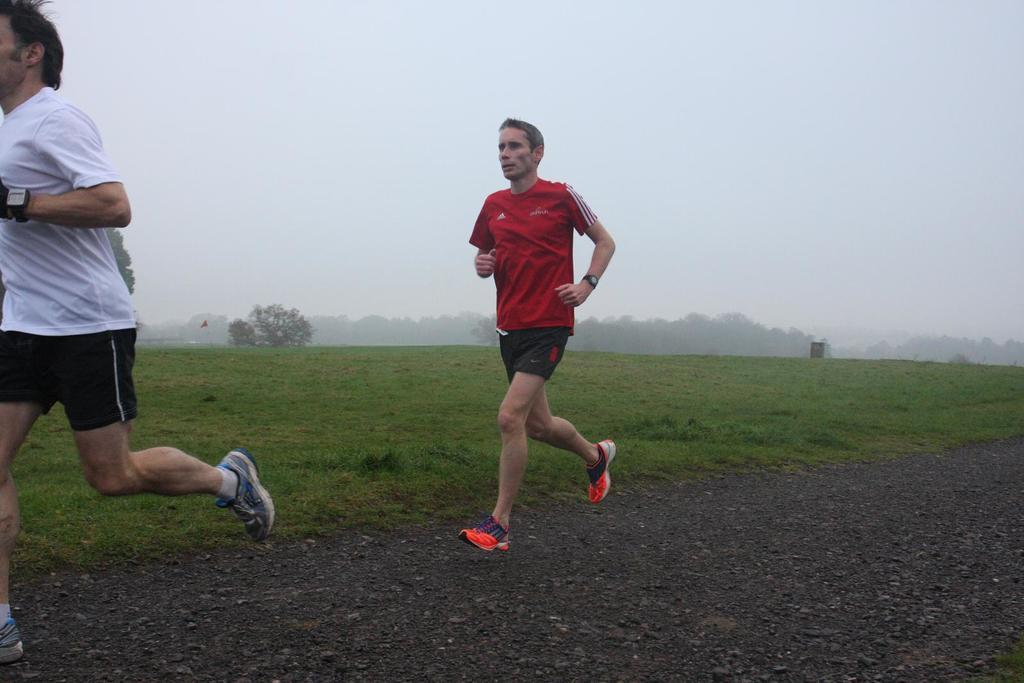How many people are in the image? There are two men in the image. What are the men doing in the image? The men are jogging. What type of terrain surrounds the men? The land around them is covered with grass. Are there any trees visible in the image? Yes, there are trees in the image. How would you describe the weather in the image? The climate is cool with fog. Who is the creator of the fog in the image? The image does not provide information about the origin of the fog, so it is not possible to determine who the creator is. 